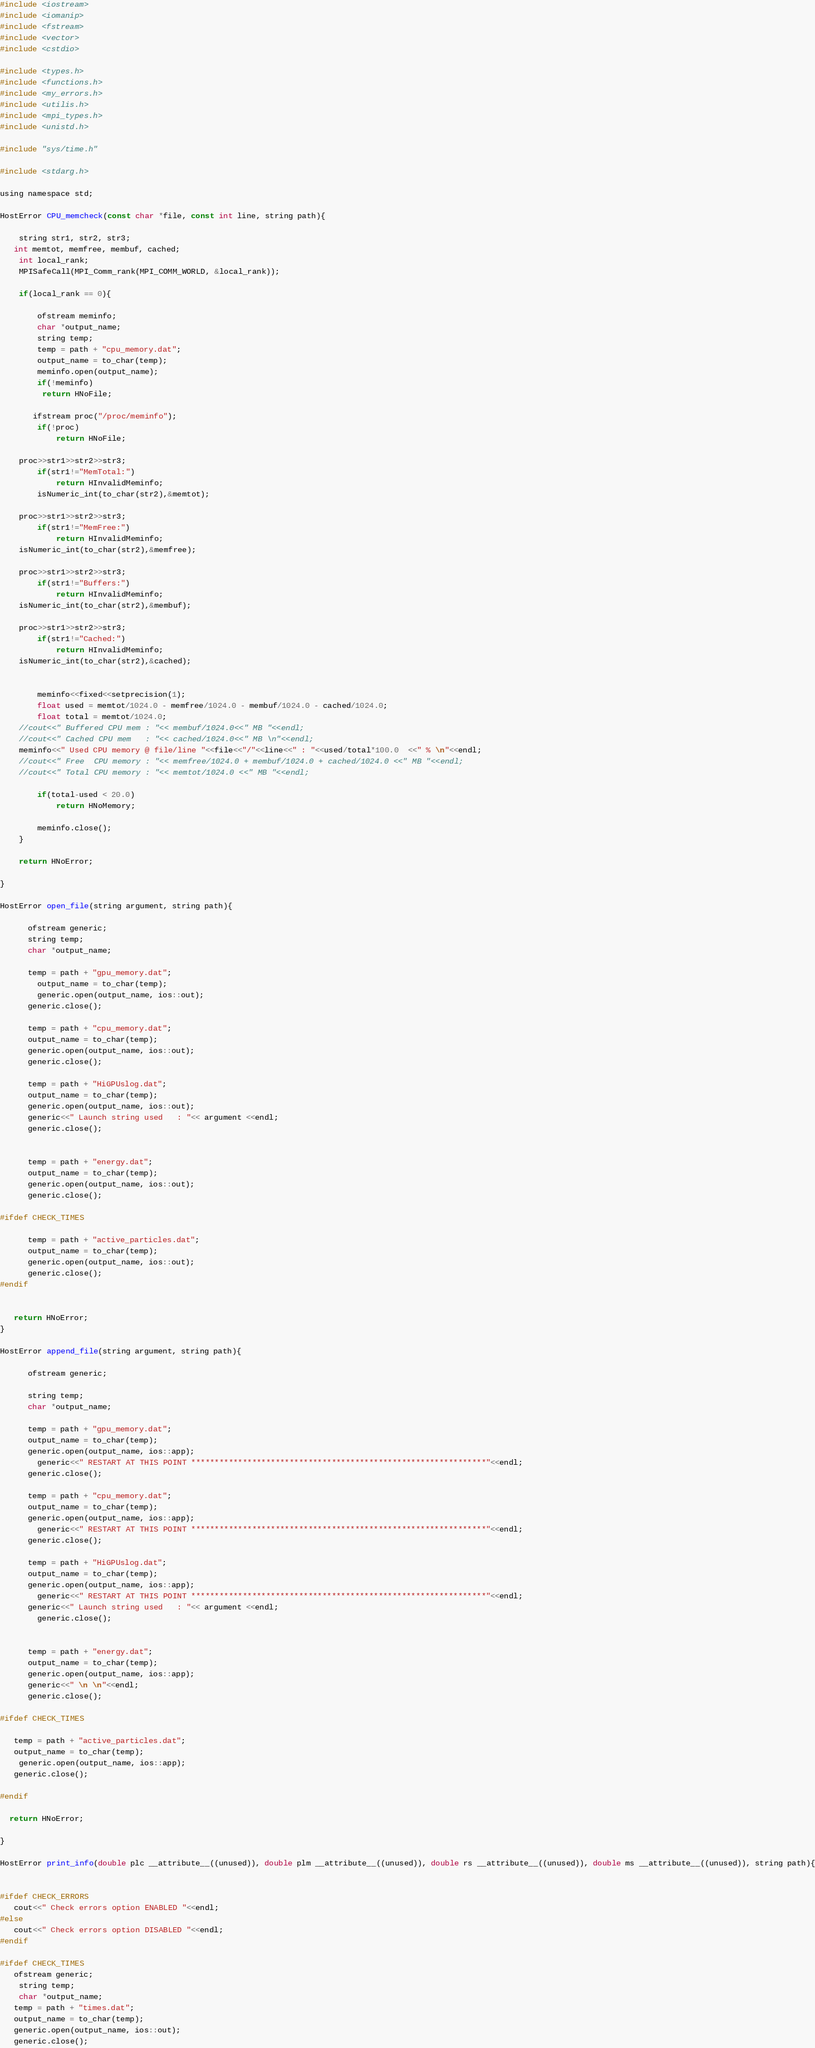<code> <loc_0><loc_0><loc_500><loc_500><_Cuda_>#include <iostream>
#include <iomanip>
#include <fstream>
#include <vector>
#include <cstdio>

#include <types.h>
#include <functions.h>
#include <my_errors.h>
#include <utilis.h>
#include <mpi_types.h>
#include <unistd.h>

#include "sys/time.h"

#include <stdarg.h>

using namespace std;

HostError CPU_memcheck(const char *file, const int line, string path){
	
	string str1, str2, str3;
   int memtot, memfree, membuf, cached;
	int local_rank;
	MPISafeCall(MPI_Comm_rank(MPI_COMM_WORLD, &local_rank));

	if(local_rank == 0){

		ofstream meminfo;
		char *output_name;
		string temp;
		temp = path + "cpu_memory.dat";
		output_name = to_char(temp);
		meminfo.open(output_name);
		if(!meminfo)
         return HNoFile;

	   ifstream proc("/proc/meminfo");
		if(!proc)
			return HNoFile;

   	proc>>str1>>str2>>str3;
		if(str1!="MemTotal:")
			return HInvalidMeminfo;
		isNumeric_int(to_char(str2),&memtot);

   	proc>>str1>>str2>>str3;
		if(str1!="MemFree:")
			return HInvalidMeminfo;
   	isNumeric_int(to_char(str2),&memfree);

   	proc>>str1>>str2>>str3;
		if(str1!="Buffers:")
			return HInvalidMeminfo;
   	isNumeric_int(to_char(str2),&membuf);

   	proc>>str1>>str2>>str3;
		if(str1!="Cached:")
			return HInvalidMeminfo;
   	isNumeric_int(to_char(str2),&cached);


		meminfo<<fixed<<setprecision(1);
		float used = memtot/1024.0 - memfree/1024.0 - membuf/1024.0 - cached/1024.0;
		float total = memtot/1024.0; 
   	//cout<<" Buffered CPU mem : "<< membuf/1024.0<<" MB "<<endl;
   	//cout<<" Cached CPU mem   : "<< cached/1024.0<<" MB \n"<<endl;
   	meminfo<<" Used CPU memory @ file/line "<<file<<"/"<<line<<" : "<<used/total*100.0  <<" % \n"<<endl;
   	//cout<<" Free  CPU memory : "<< memfree/1024.0 + membuf/1024.0 + cached/1024.0 <<" MB "<<endl;
   	//cout<<" Total CPU memory : "<< memtot/1024.0 <<" MB "<<endl;

		if(total-used < 20.0)
			return HNoMemory;

		meminfo.close();
	}

	return HNoError;

}

HostError open_file(string argument, string path){

      ofstream generic;
      string temp;
      char *output_name;

      temp = path + "gpu_memory.dat";
		output_name = to_char(temp);
		generic.open(output_name, ios::out);
      generic.close();

      temp = path + "cpu_memory.dat";
      output_name = to_char(temp);
      generic.open(output_name, ios::out);
      generic.close();

      temp = path + "HiGPUslog.dat";
      output_name = to_char(temp);
      generic.open(output_name, ios::out);
      generic<<" Launch string used   : "<< argument <<endl;
      generic.close();


      temp = path + "energy.dat";
      output_name = to_char(temp);
      generic.open(output_name, ios::out);
      generic.close();

#ifdef CHECK_TIMES

      temp = path + "active_particles.dat";
      output_name = to_char(temp);
      generic.open(output_name, ios::out);
      generic.close();
#endif


   return HNoError;
}

HostError append_file(string argument, string path){

      ofstream generic;
    
      string temp;
      char *output_name;

      temp = path + "gpu_memory.dat";
      output_name = to_char(temp);
      generic.open(output_name, ios::app);
		generic<<" RESTART AT THIS POINT ***************************************************************"<<endl;
      generic.close();

      temp = path + "cpu_memory.dat";
      output_name = to_char(temp);
      generic.open(output_name, ios::app);
		generic<<" RESTART AT THIS POINT ***************************************************************"<<endl;
      generic.close();

      temp = path + "HiGPUslog.dat";
      output_name = to_char(temp);
      generic.open(output_name, ios::app);
		generic<<" RESTART AT THIS POINT ***************************************************************"<<endl;
      generic<<" Launch string used   : "<< argument <<endl;
		generic.close();


      temp = path + "energy.dat";
      output_name = to_char(temp);
      generic.open(output_name, ios::app);
      generic<<" \n \n"<<endl;
      generic.close();

#ifdef CHECK_TIMES

   temp = path + "active_particles.dat";
   output_name = to_char(temp);
	generic.open(output_name, ios::app);
   generic.close();

#endif

  return HNoError;

}

HostError print_info(double plc __attribute__((unused)), double plm __attribute__((unused)), double rs __attribute__((unused)), double ms __attribute__((unused)), string path){


#ifdef CHECK_ERRORS
   cout<<" Check errors option ENABLED "<<endl;
#else
   cout<<" Check errors option DISABLED "<<endl;
#endif

#ifdef CHECK_TIMES
   ofstream generic;
	string temp;
	char *output_name;
   temp = path + "times.dat";
   output_name = to_char(temp);
   generic.open(output_name, ios::out);
   generic.close();</code> 